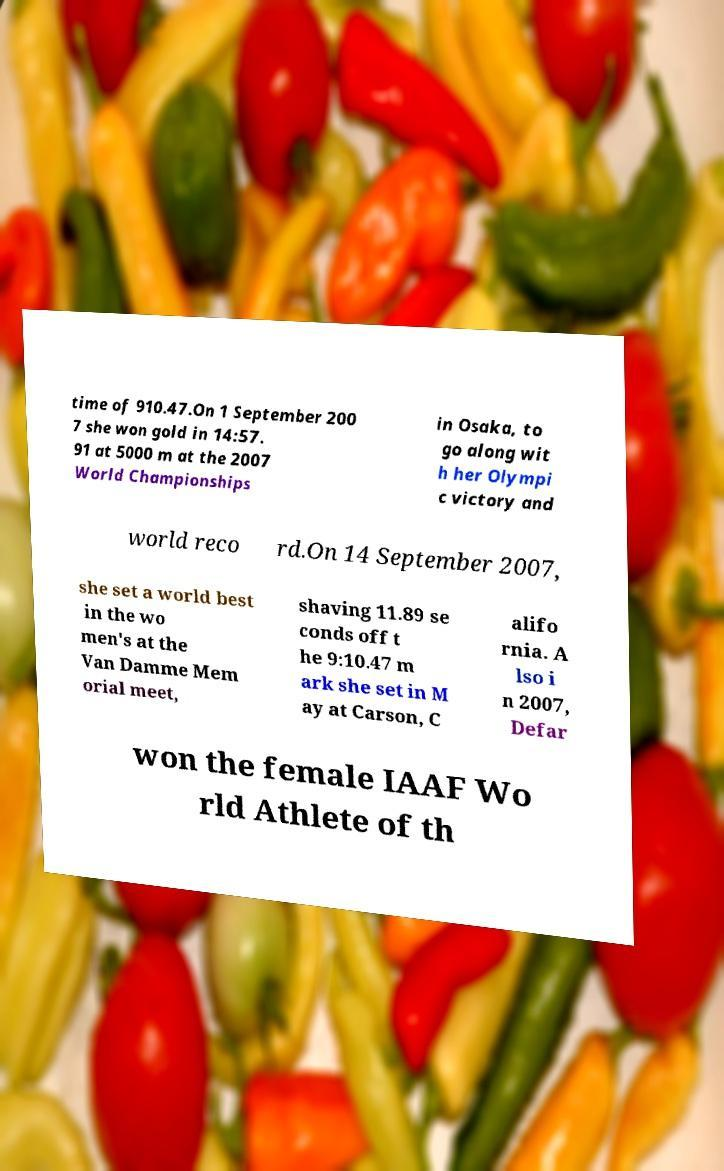I need the written content from this picture converted into text. Can you do that? time of 910.47.On 1 September 200 7 she won gold in 14:57. 91 at 5000 m at the 2007 World Championships in Osaka, to go along wit h her Olympi c victory and world reco rd.On 14 September 2007, she set a world best in the wo men's at the Van Damme Mem orial meet, shaving 11.89 se conds off t he 9:10.47 m ark she set in M ay at Carson, C alifo rnia. A lso i n 2007, Defar won the female IAAF Wo rld Athlete of th 